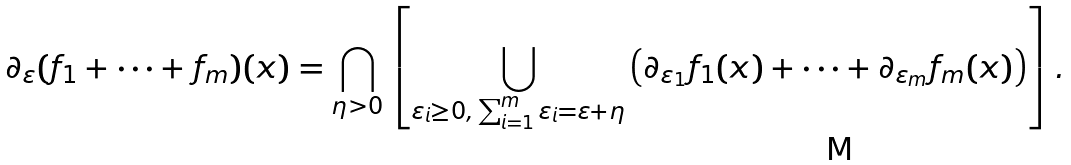<formula> <loc_0><loc_0><loc_500><loc_500>\partial _ { \varepsilon } ( f _ { 1 } + \cdots + f _ { m } ) ( x ) = \bigcap _ { \eta > 0 } \left [ \bigcup _ { \varepsilon _ { i } \geq 0 , \, \sum _ { i = 1 } ^ { m } \varepsilon _ { i } = \varepsilon + \eta } \left ( \partial _ { \varepsilon _ { 1 } } f _ { 1 } ( x ) + \cdots + \partial _ { \varepsilon _ { m } } f _ { m } ( x ) \right ) \right ] .</formula> 